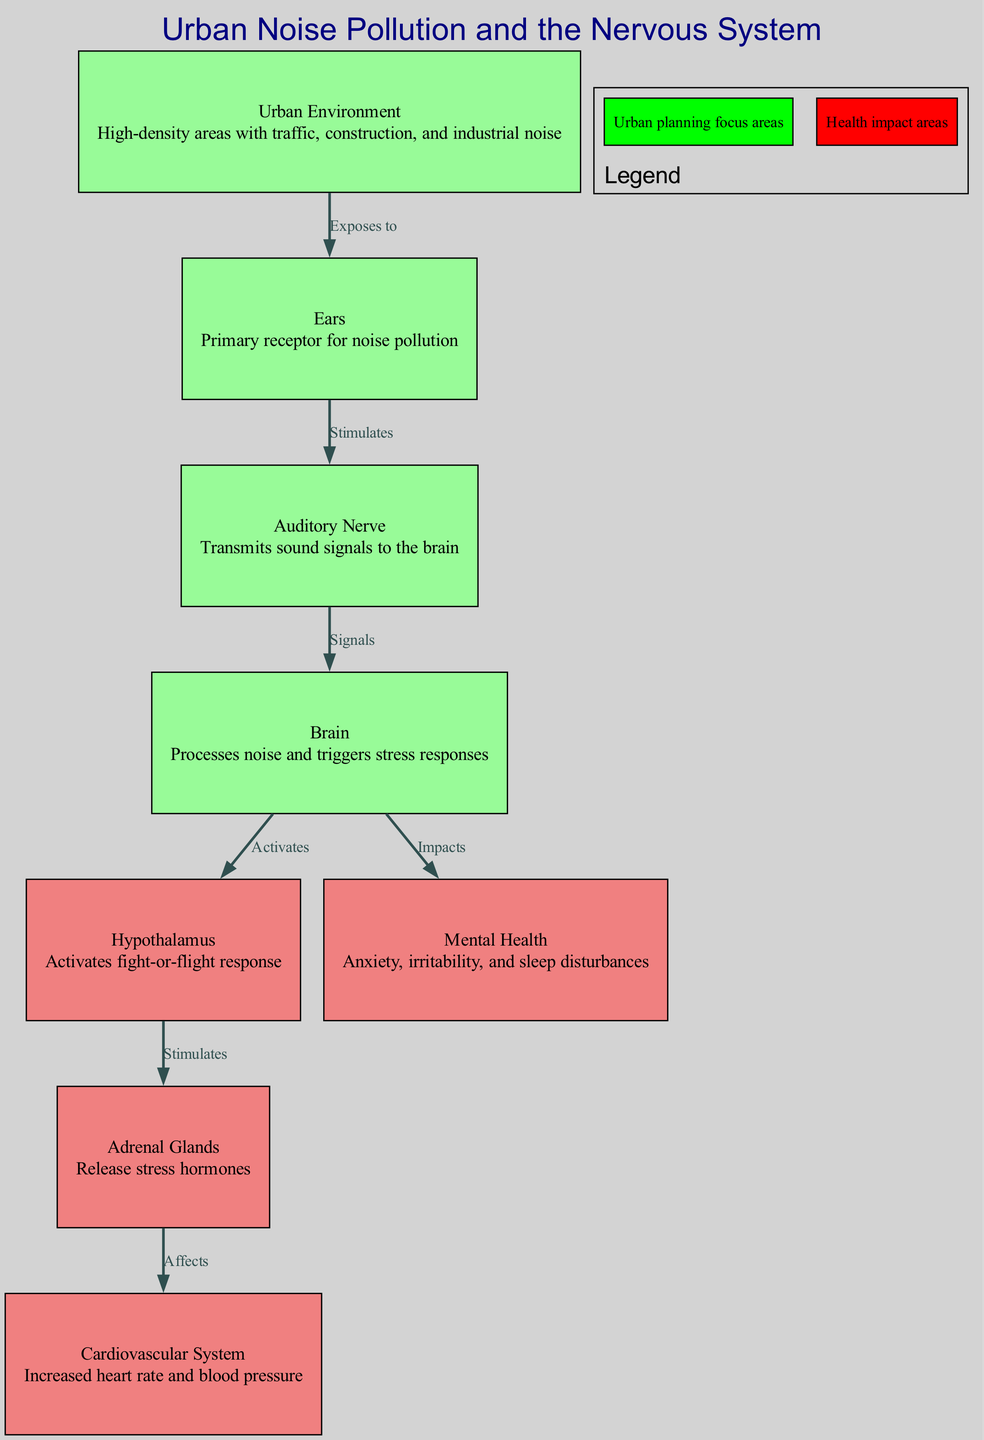What is the primary receptor for noise pollution? The diagram indicates that the "Ears" are the primary receptor for noise pollution in urban environments, as it is labeled directly in the related node.
Answer: Ears How many nodes are there in the diagram? By counting all the distinct nodes provided in the data, we find there are a total of eight nodes listed.
Answer: 8 What type of health issues are impacted in the diagram? The node "Mental Health" describes various issues such as anxiety, irritability, and sleep disturbances, directly showing the health impact areas related to noise pollution.
Answer: Anxiety, irritability, sleep disturbances What does the "Hypothalamus" activate? The node labeled "Hypothalamus" indicates that it activates the 'fight-or-flight' response, based on the connection described in the directed flow of the diagram.
Answer: Fight-or-flight response How does noise pollution initially affect the human system according to the diagram? According to the flow, noise pollution from the "Urban Environment" exposes individuals to noise, which is then processed by "Ears," leading to further impacts on the nervous system.
Answer: Exposes to noise What is the connection between the "Adrenal Glands" and the "Cardiovascular System"? The diagram shows that the "Adrenal Glands" release stress hormones that affect the "Cardiovascular System," leading to increased heart rate and blood pressure as indicated along the directed edge.
Answer: Affects What color represents urban planning focus areas in the legend? The legend in the diagram specifies that the color green represents urban planning focus areas, providing visual guidance on the content related to urban design.
Answer: Green How many edges are there in the diagram? By counting the relationships (edges) established between the nodes, we can determine that there are a total of seven edges outlined in the diagram.
Answer: 7 What is the effect of noise signals processed by the "Brain"? The node labeled "Brain" shows that it processes noise signals and subsequently triggers 'stress responses', highlighting the direct impact of noise on cognitive functions.
Answer: Triggers stress responses 